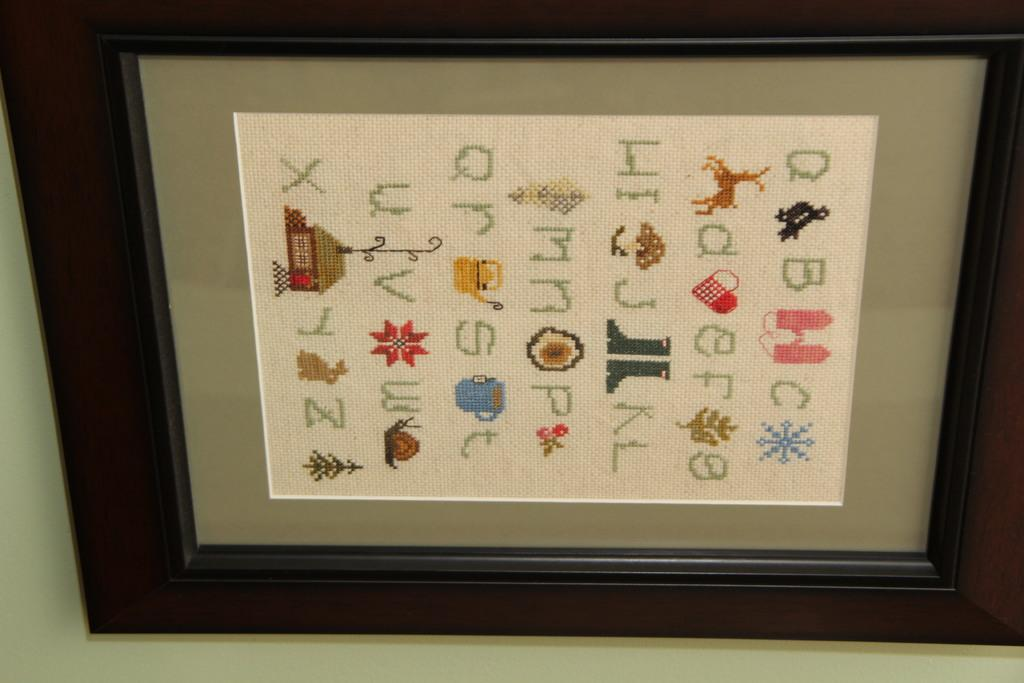<image>
Relay a brief, clear account of the picture shown. A crossstich version of the alphabet is framed. 